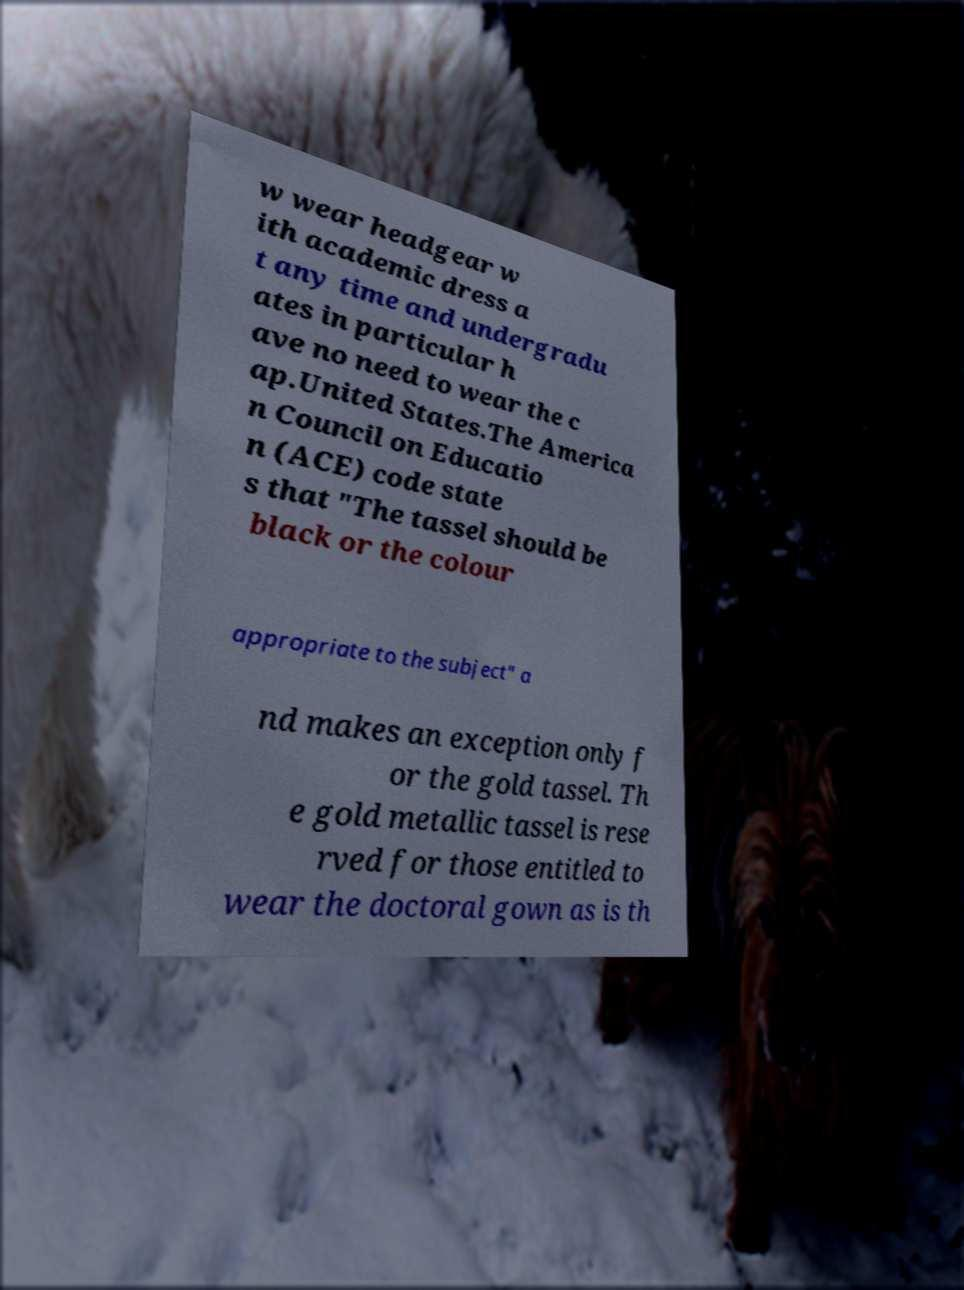What messages or text are displayed in this image? I need them in a readable, typed format. w wear headgear w ith academic dress a t any time and undergradu ates in particular h ave no need to wear the c ap.United States.The America n Council on Educatio n (ACE) code state s that "The tassel should be black or the colour appropriate to the subject" a nd makes an exception only f or the gold tassel. Th e gold metallic tassel is rese rved for those entitled to wear the doctoral gown as is th 